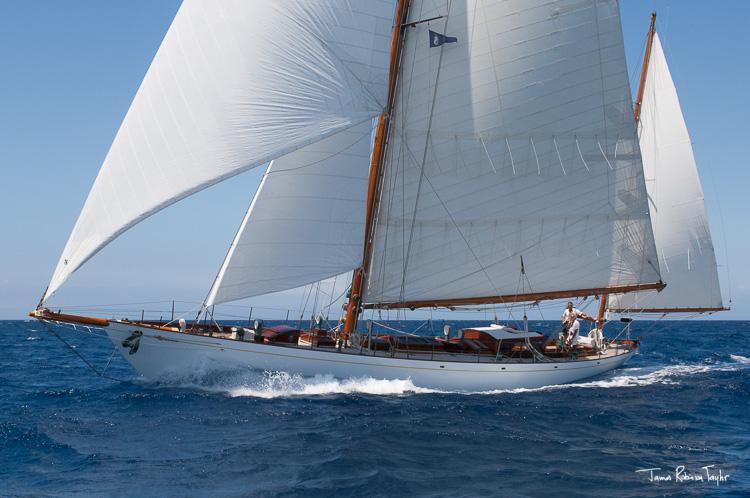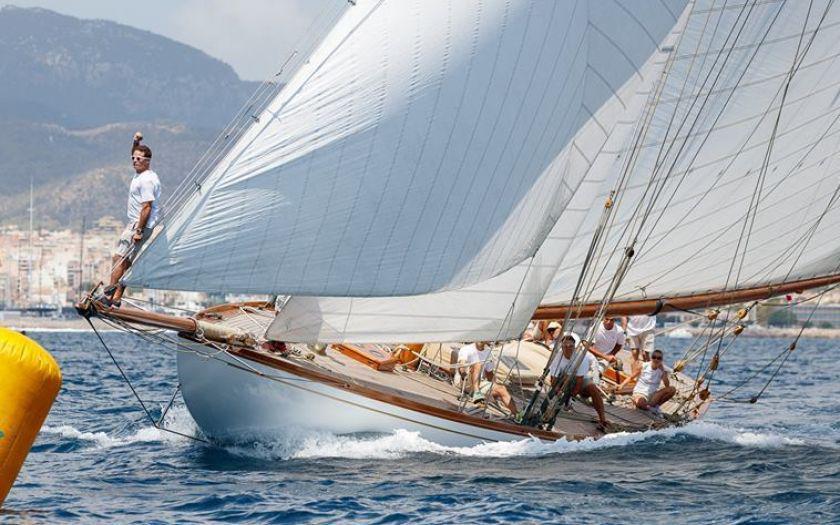The first image is the image on the left, the second image is the image on the right. Assess this claim about the two images: "In one image, a moving sailboat's three triangular sails are angled with their peaks toward the upper left.". Correct or not? Answer yes or no. No. 